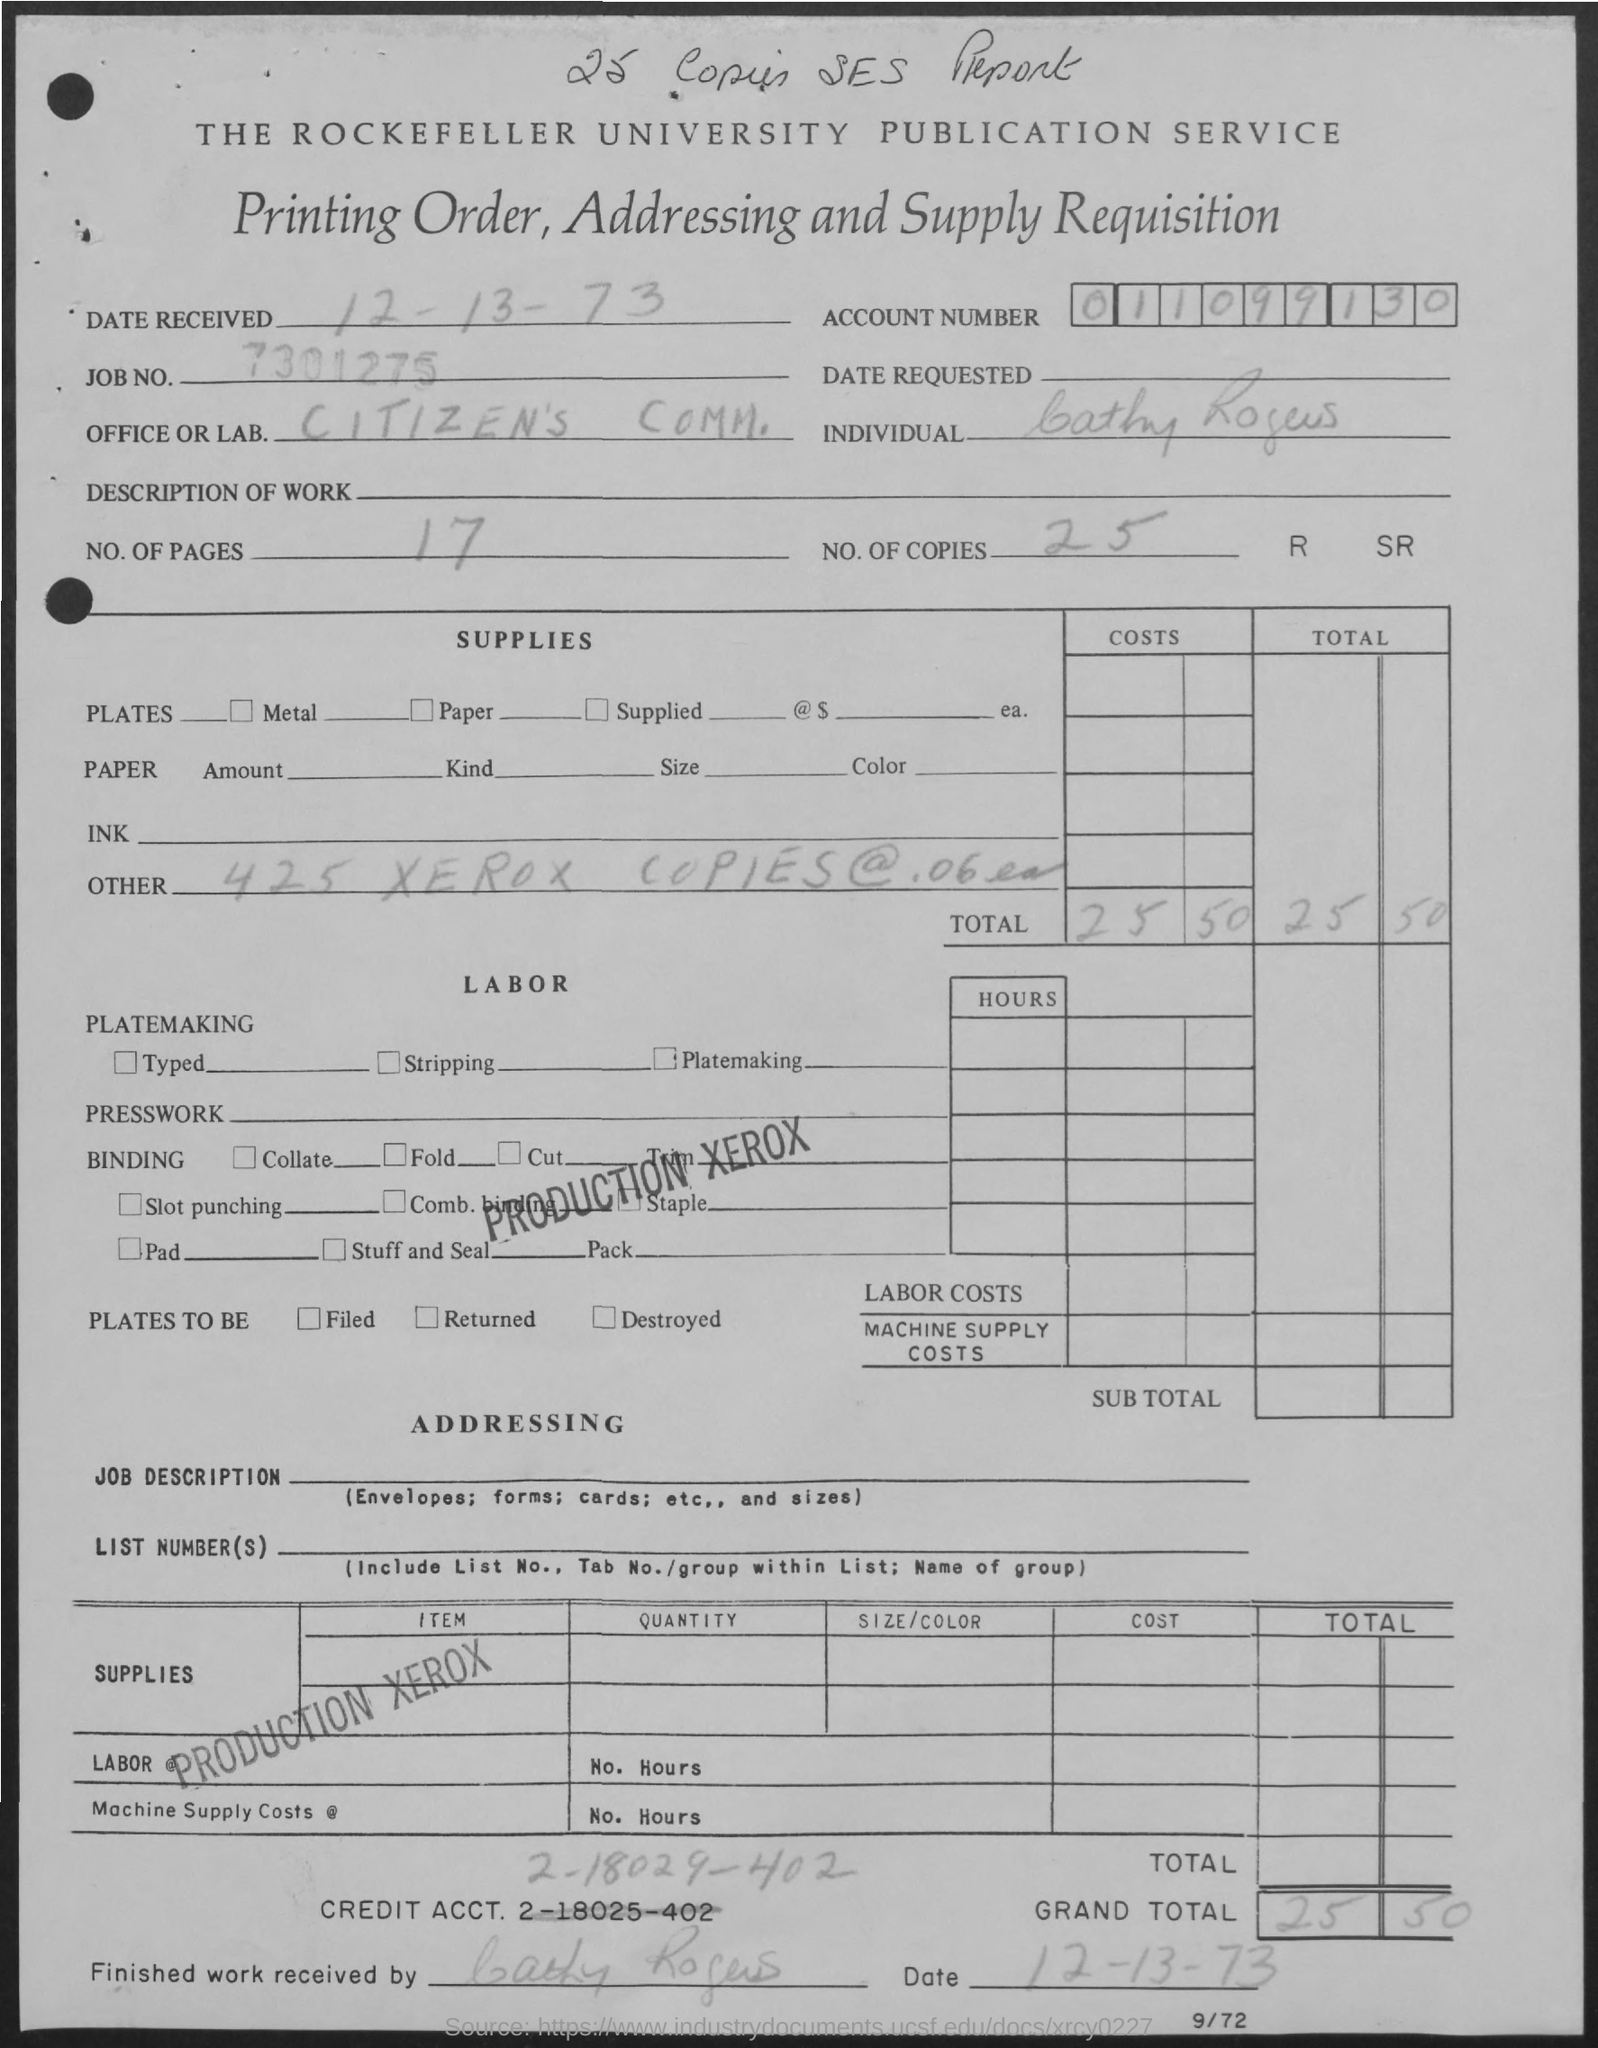Which service is mentioned at the top of the page?
Give a very brief answer. The Rockefeller University Publication service. What is the Account Number?
Ensure brevity in your answer.  011099130. What is the JOB NO.?
Keep it short and to the point. 7301275. Which office/lab is mentioned?
Keep it short and to the point. CITIZEN'S COMM. How many pages are there?
Make the answer very short. 17. How many copies are mentioned?
Ensure brevity in your answer.  25. 